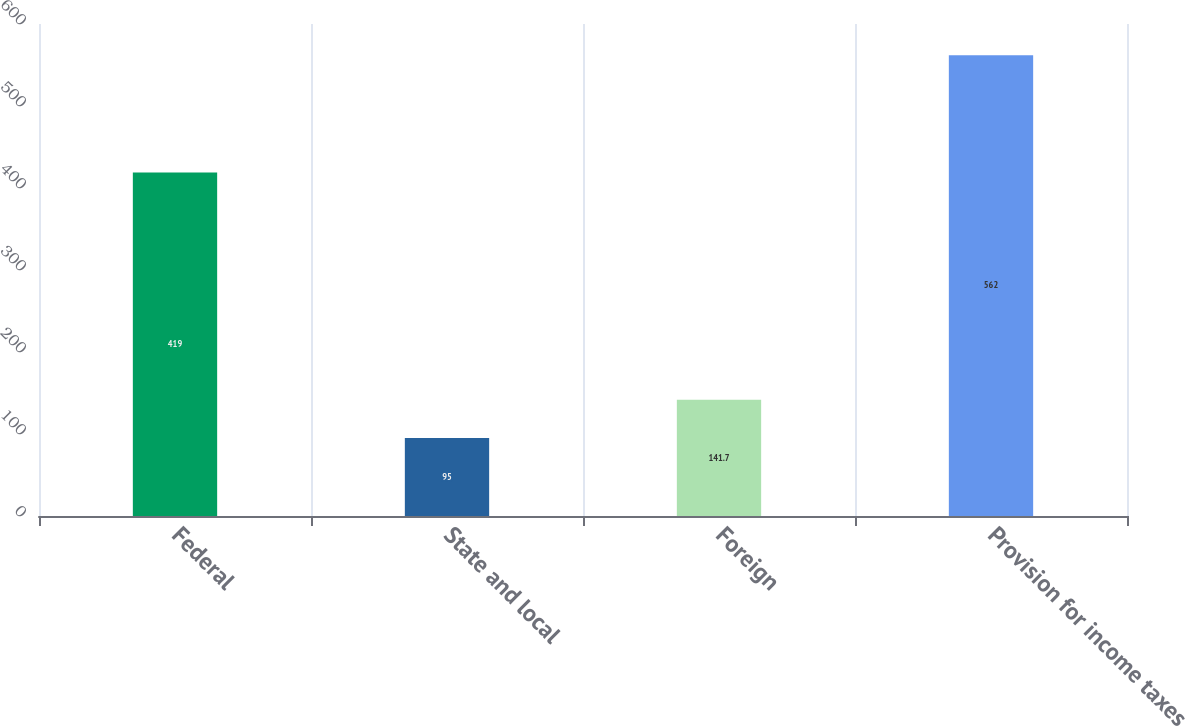<chart> <loc_0><loc_0><loc_500><loc_500><bar_chart><fcel>Federal<fcel>State and local<fcel>Foreign<fcel>Provision for income taxes<nl><fcel>419<fcel>95<fcel>141.7<fcel>562<nl></chart> 